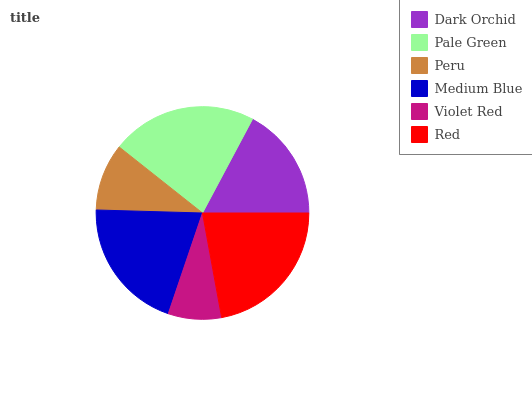Is Violet Red the minimum?
Answer yes or no. Yes. Is Pale Green the maximum?
Answer yes or no. Yes. Is Peru the minimum?
Answer yes or no. No. Is Peru the maximum?
Answer yes or no. No. Is Pale Green greater than Peru?
Answer yes or no. Yes. Is Peru less than Pale Green?
Answer yes or no. Yes. Is Peru greater than Pale Green?
Answer yes or no. No. Is Pale Green less than Peru?
Answer yes or no. No. Is Medium Blue the high median?
Answer yes or no. Yes. Is Dark Orchid the low median?
Answer yes or no. Yes. Is Violet Red the high median?
Answer yes or no. No. Is Pale Green the low median?
Answer yes or no. No. 